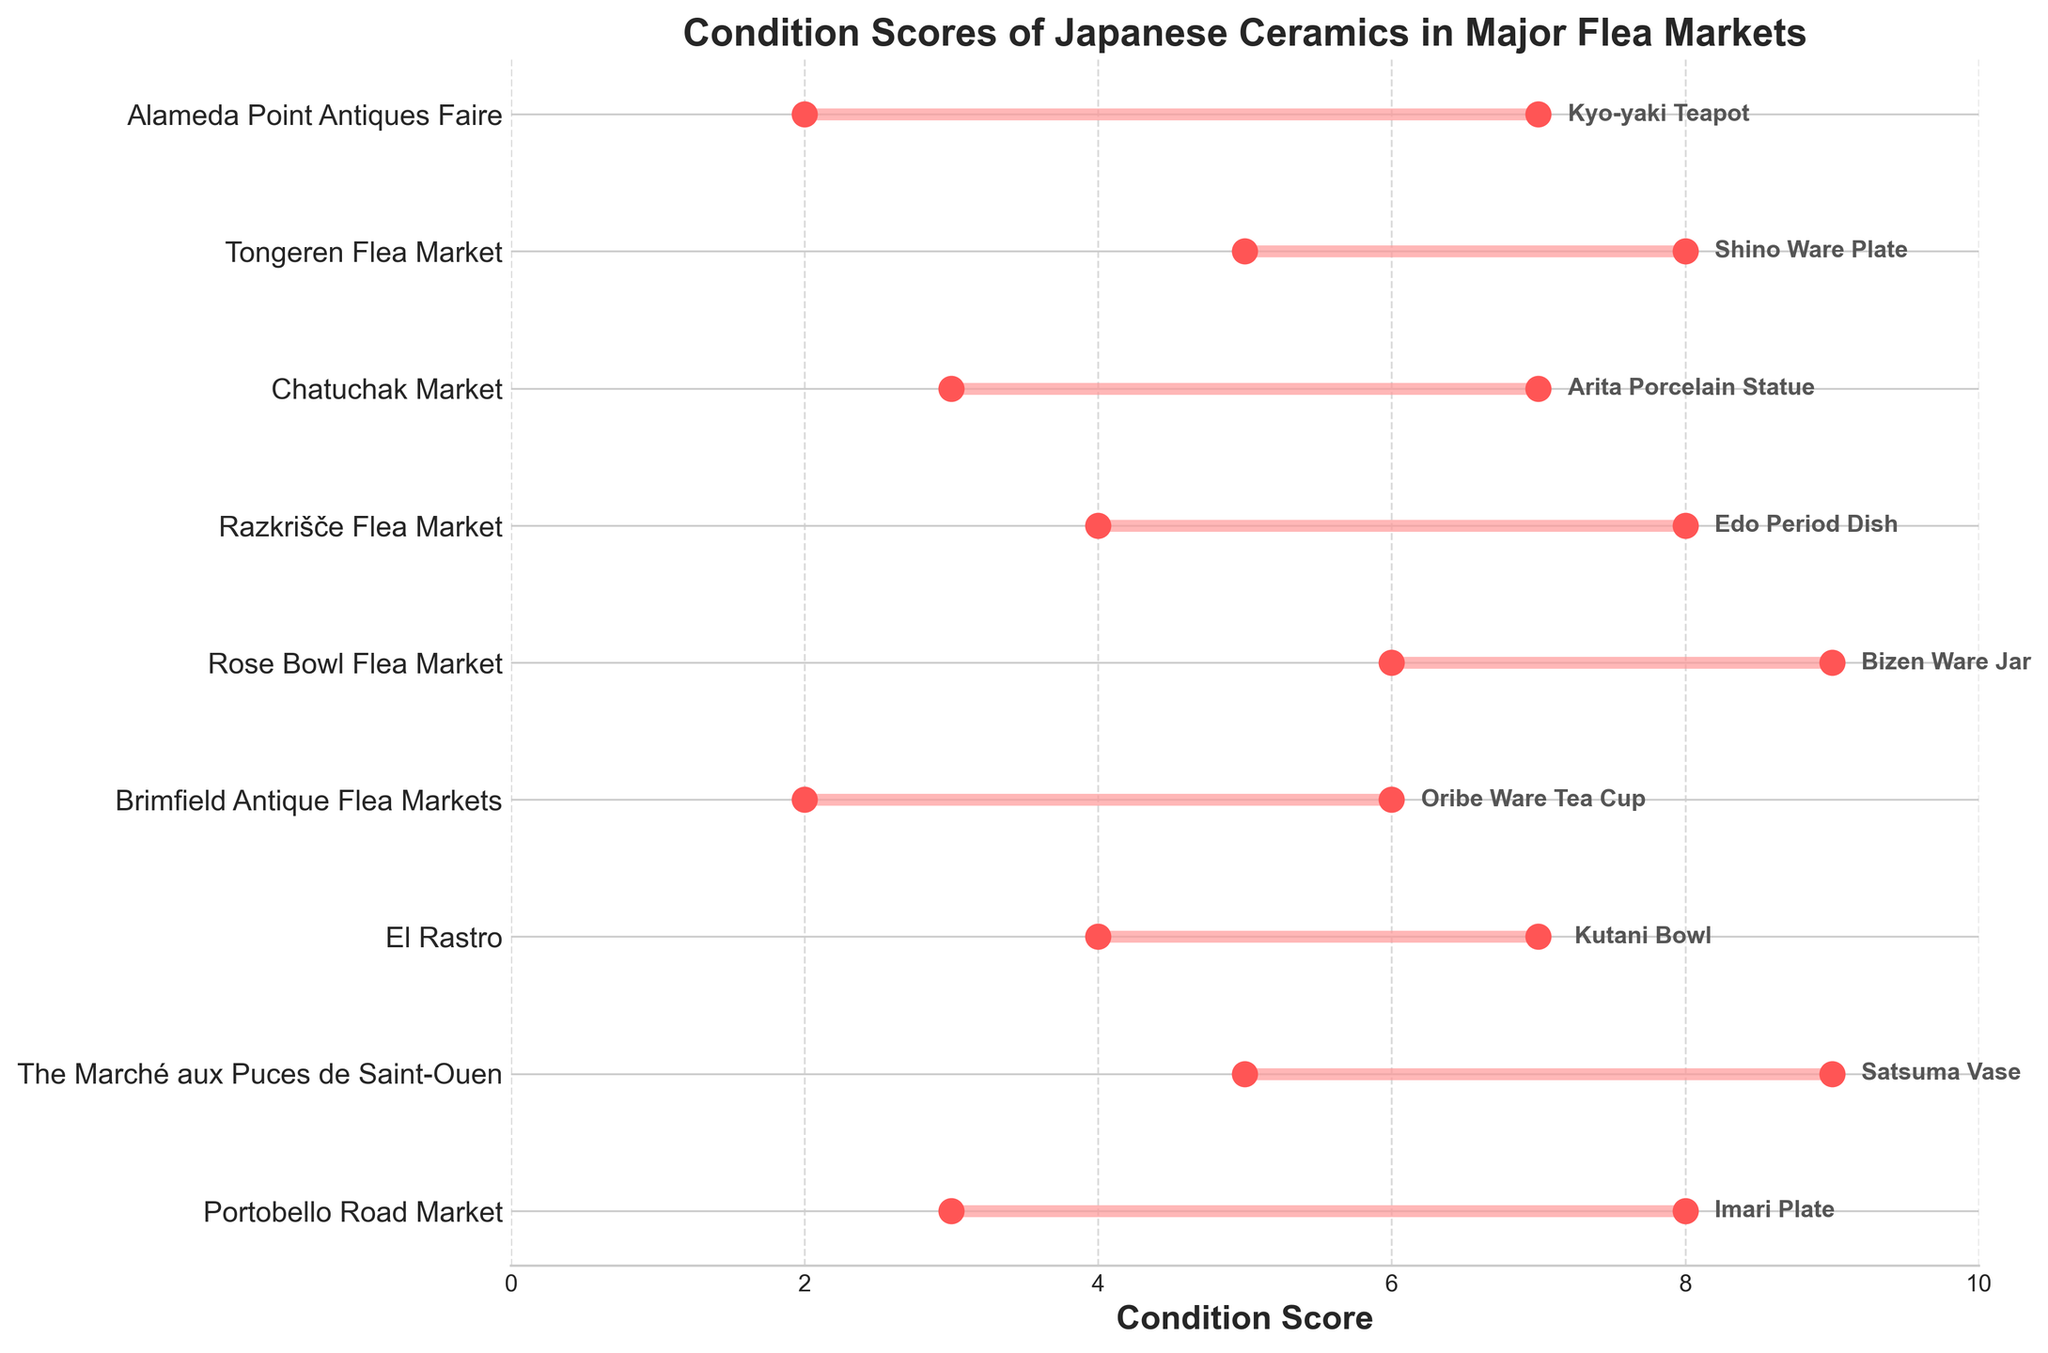How many flea markets are presented in the plot? Count the number of unique flea markets listed on the y-axis.
Answer: 9 What is the title of the figure? Look at the top of the figure to read the title.
Answer: Condition Scores of Japanese Ceramics in Major Flea Markets Which flea market has the item with the highest maximum condition score? Evaluate the maximum condition scores for each market, and identify the one with the highest value. The maximum condition score is 9, and it appears for the Satsuma Vase at The Marché aux Puces de Saint-Ouen and the Bizen Ware Jar at the Rose Bowl Flea Market.
Answer: The Marché aux Puces de Saint-Ouen and Rose Bowl Flea Market What is the range of condition scores for the Imari Plate found in Portobello Road Market? Identify the minimum and maximum condition scores for the Imari Plate.
Answer: 3 to 8 Which item at the Alameda Point Antiques Faire has a condition score range from 2 to 7? Check the item linked with Alameda Point Antiques Faire on the y-axis and read its condition score range.
Answer: Kyo-yaki Teapot Which flea market has the item with the smallest range in condition scores? Determine the range of scores (difference between maximum and minimum) for each market and identify the smallest one. The Oribe Ware Tea Cup at Brimfield Antique Flea Markets has the smallest range (4).
Answer: Brimfield Antique Flea Markets What are the minimum and maximum condition scores for the Arita Porcelain Statue found in Chatuchak Market? Identify the condition scores for the Arita Porcelain Statue listed next to the market name.
Answer: 3 and 7 How does the condition score range of the Edo Period Dish at Razkrišče Flea Market compare to the Shino Ware Plate at Tongeren Flea Market? Compare the ranges: Edo Period Dish ranges from 4 to 8 (range = 4), Shino Ware Plate ranges from 5 to 8 (range = 3).
Answer: Edo Period Dish has a larger range Which flea market offers an item with a minimum condition score of 6? Find the market where the item has a minimum condition score of 6.
Answer: Rose Bowl Flea Market What is the average maximum condition score of the items across all flea markets? Sum all the maximum condition scores and divide by the number of flea markets (9). The maximum scores are 8, 9, 7, 6, 9, 8, 7, 8, 7. Sum = 69, average = 69/9 = 7.67
Answer: 7.67 